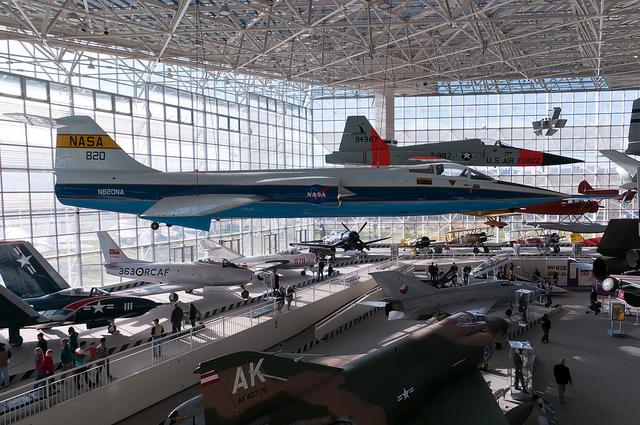Are any of these plane moving?
Concise answer only. No. What letters are on the green and brown plane?
Concise answer only. Ak. Are only two people standing and/or walking?
Quick response, please. No. 